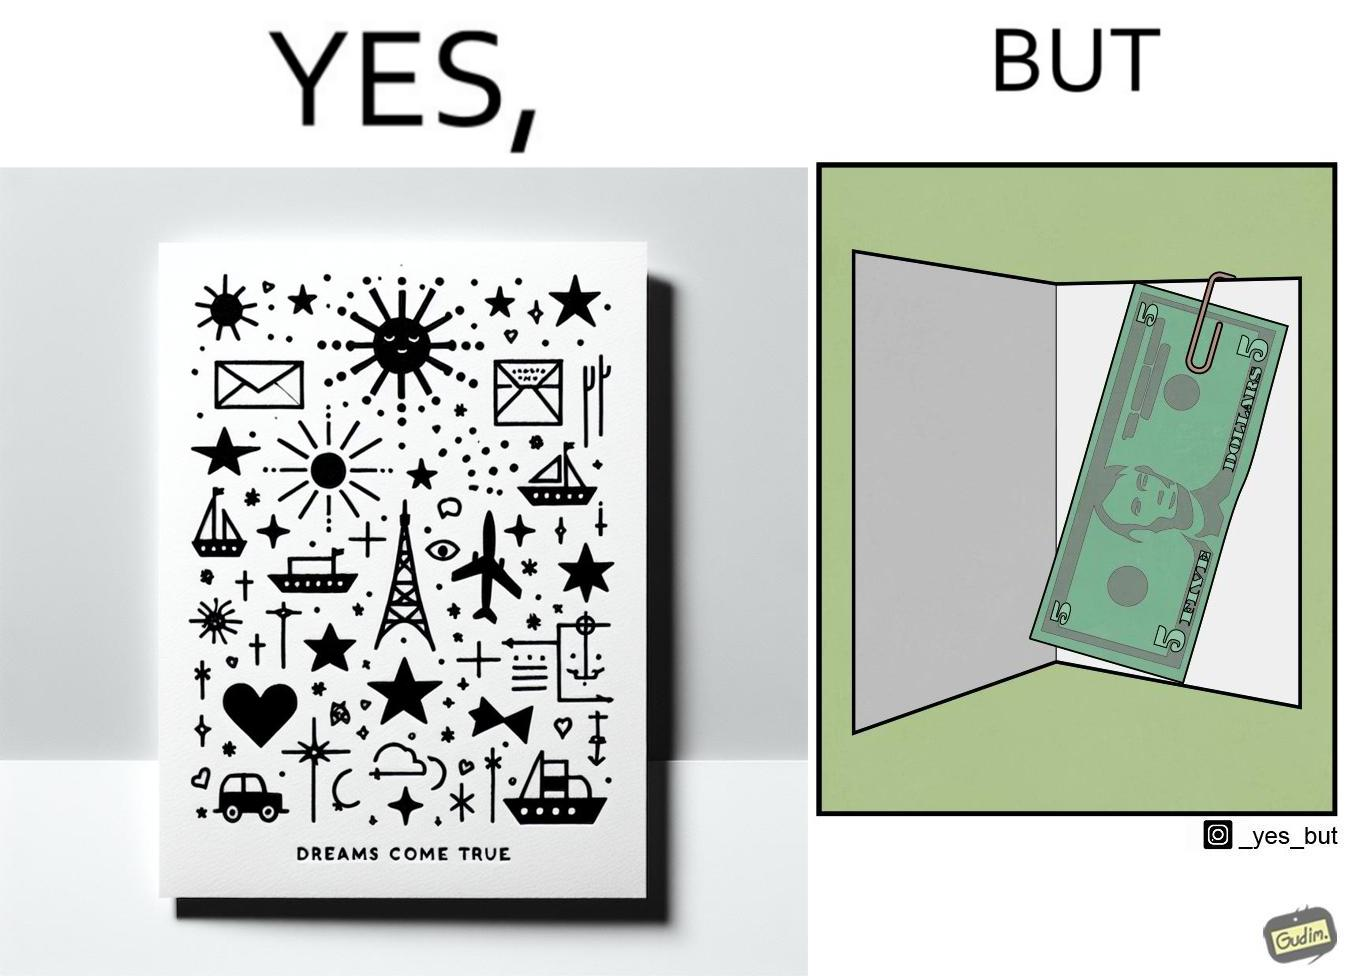What is shown in this image? The overall image is funny because while the front of the card gives hope that the person receiving this card will have one of their dreams come true but opening the card reveals only 5 dollars which is nowhere enough to fulfil any kind of dream. 